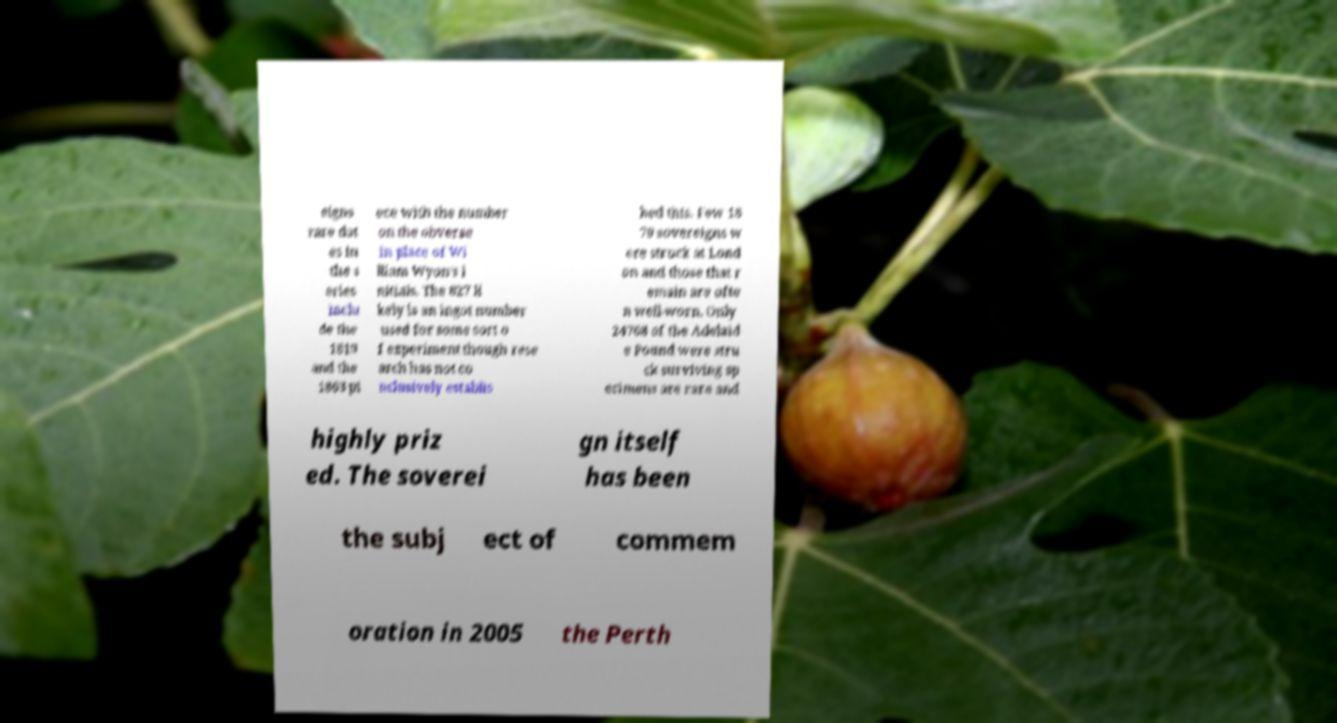Can you read and provide the text displayed in the image?This photo seems to have some interesting text. Can you extract and type it out for me? eigns rare dat es in the s eries inclu de the 1819 and the 1863 pi ece with the number on the obverse in place of Wi lliam Wyon's i nitials. The 827 li kely is an ingot number used for some sort o f experiment though rese arch has not co nclusively establis hed this. Few 18 79 sovereigns w ere struck at Lond on and those that r emain are ofte n well-worn. Only 24768 of the Adelaid e Pound were stru ck surviving sp ecimens are rare and highly priz ed. The soverei gn itself has been the subj ect of commem oration in 2005 the Perth 